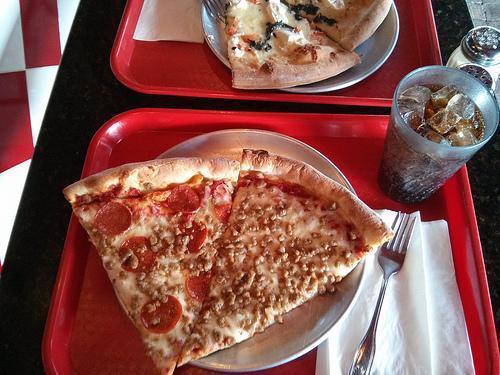How many kinds of slices?
Give a very brief answer. 2. 